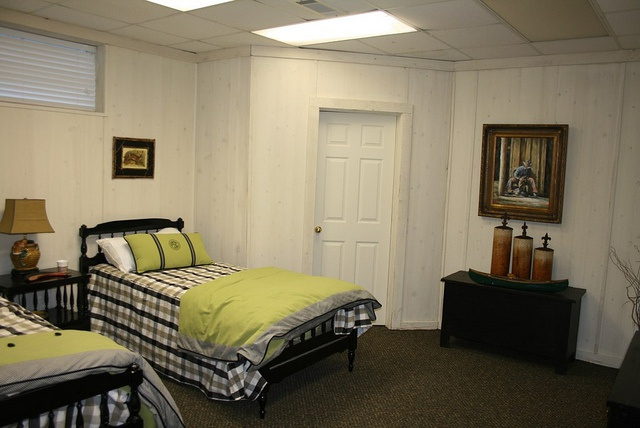Describe the objects in this image and their specific colors. I can see bed in gray, black, olive, and khaki tones, bed in gray, black, tan, and darkgray tones, and cup in gray, tan, and maroon tones in this image. 